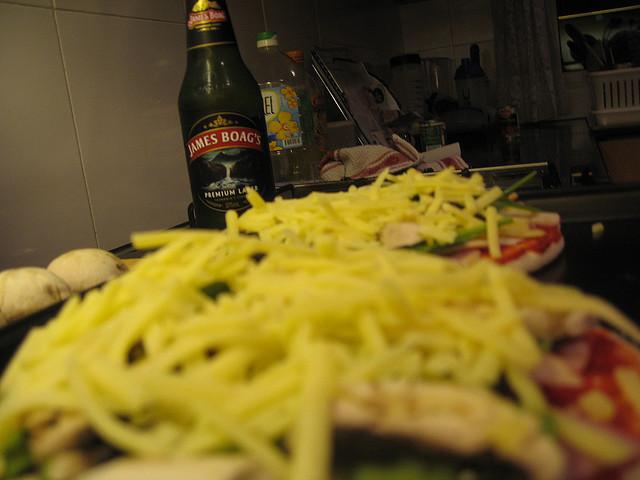Is there pasta in the photo?
Concise answer only. No. What is the name of the beer?
Write a very short answer. James boag's. Is the bottle glass?
Be succinct. Yes. 